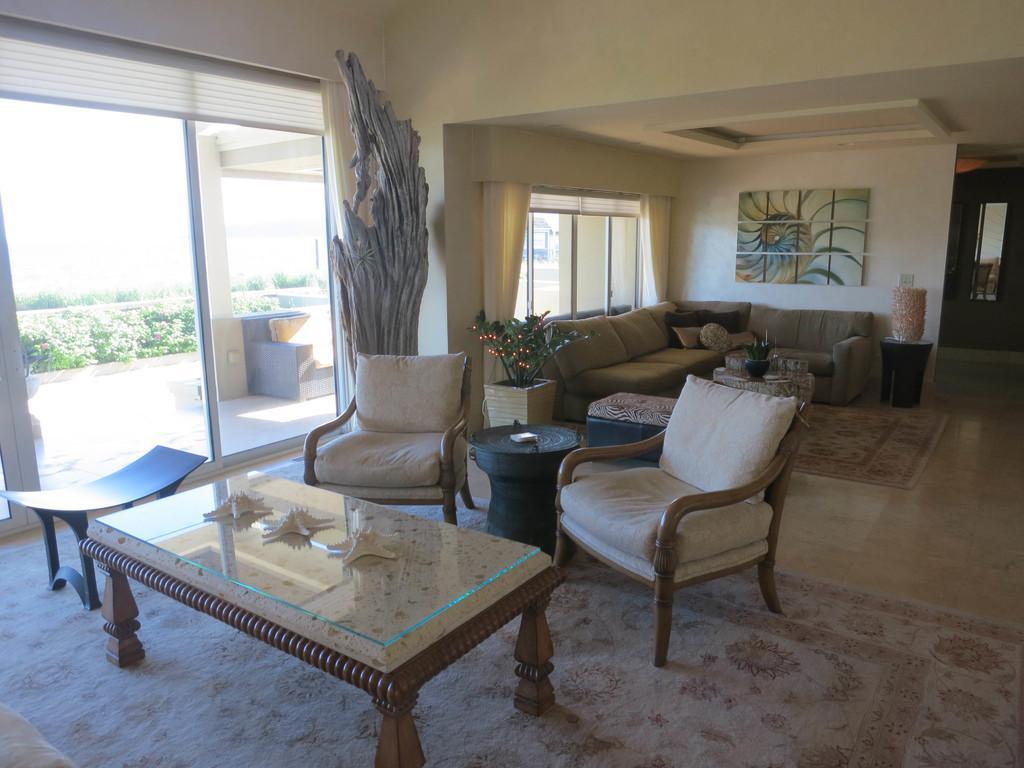Describe this image in one or two sentences. As we can see in the image there is a white color wall, photo frame, windows, sofas, chairs and a table. 